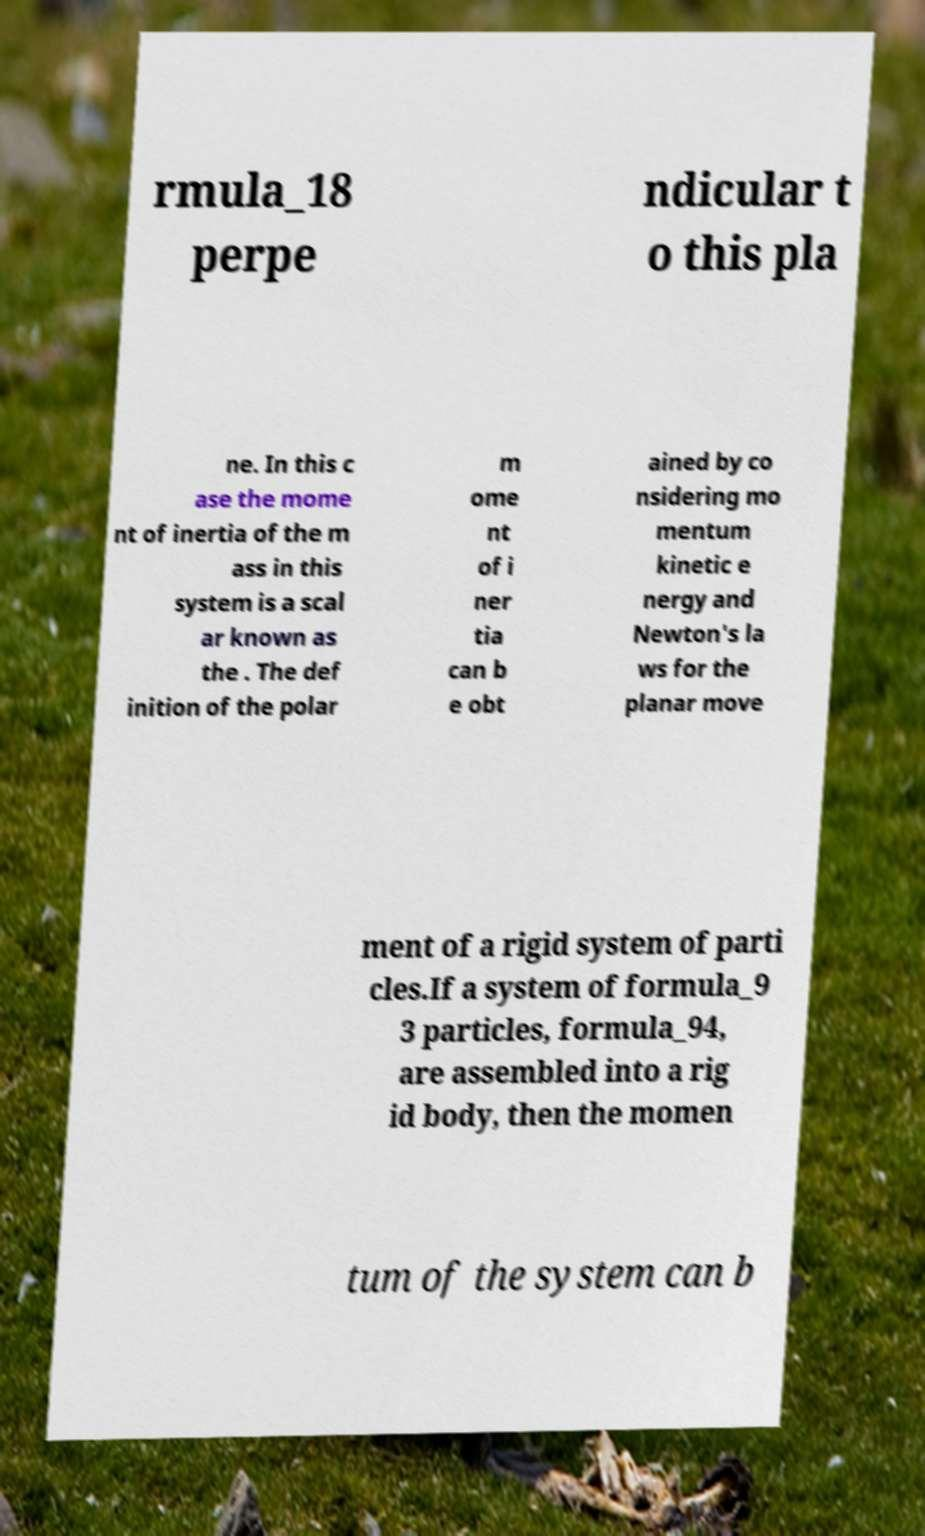For documentation purposes, I need the text within this image transcribed. Could you provide that? rmula_18 perpe ndicular t o this pla ne. In this c ase the mome nt of inertia of the m ass in this system is a scal ar known as the . The def inition of the polar m ome nt of i ner tia can b e obt ained by co nsidering mo mentum kinetic e nergy and Newton's la ws for the planar move ment of a rigid system of parti cles.If a system of formula_9 3 particles, formula_94, are assembled into a rig id body, then the momen tum of the system can b 